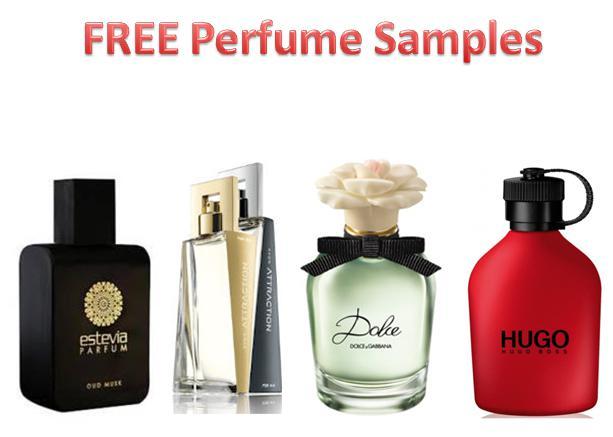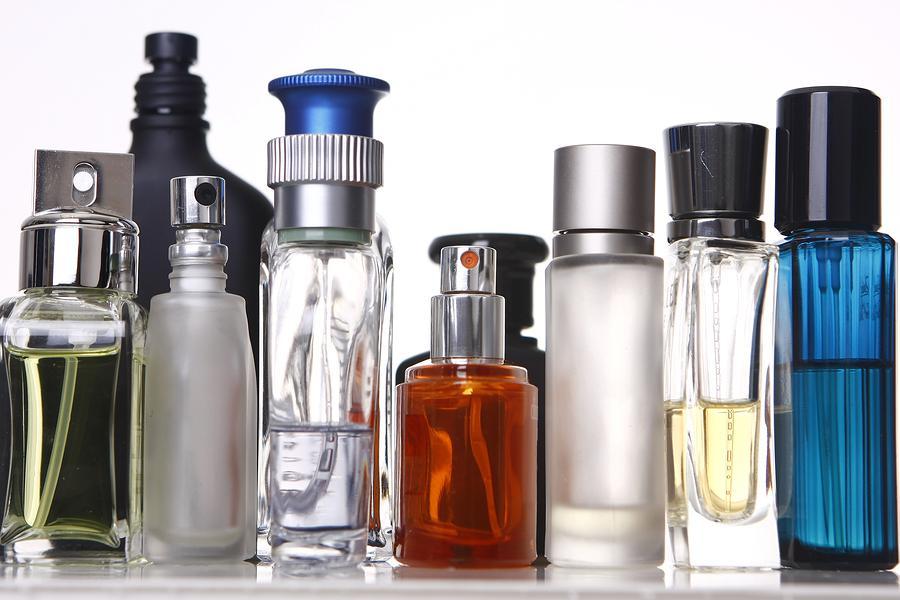The first image is the image on the left, the second image is the image on the right. Examine the images to the left and right. Is the description "There are 9 or more label-less perfume bottles." accurate? Answer yes or no. Yes. The first image is the image on the left, the second image is the image on the right. Assess this claim about the two images: "In both images the products are all of varying heights.". Correct or not? Answer yes or no. No. 